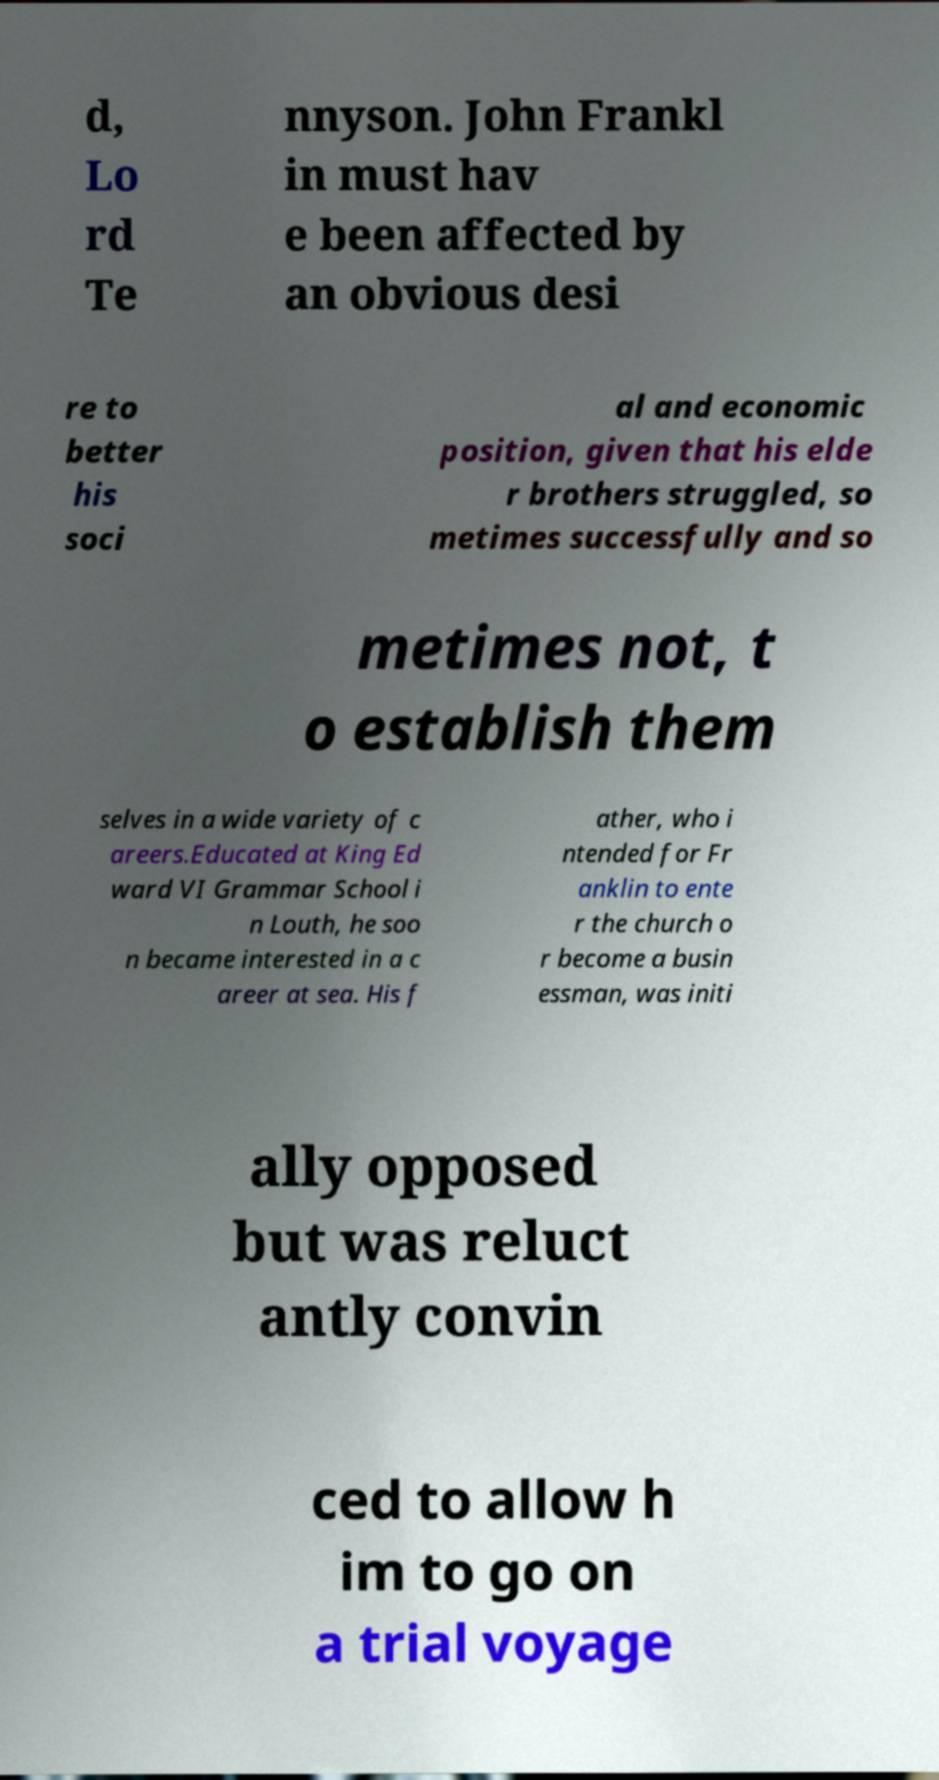I need the written content from this picture converted into text. Can you do that? d, Lo rd Te nnyson. John Frankl in must hav e been affected by an obvious desi re to better his soci al and economic position, given that his elde r brothers struggled, so metimes successfully and so metimes not, t o establish them selves in a wide variety of c areers.Educated at King Ed ward VI Grammar School i n Louth, he soo n became interested in a c areer at sea. His f ather, who i ntended for Fr anklin to ente r the church o r become a busin essman, was initi ally opposed but was reluct antly convin ced to allow h im to go on a trial voyage 